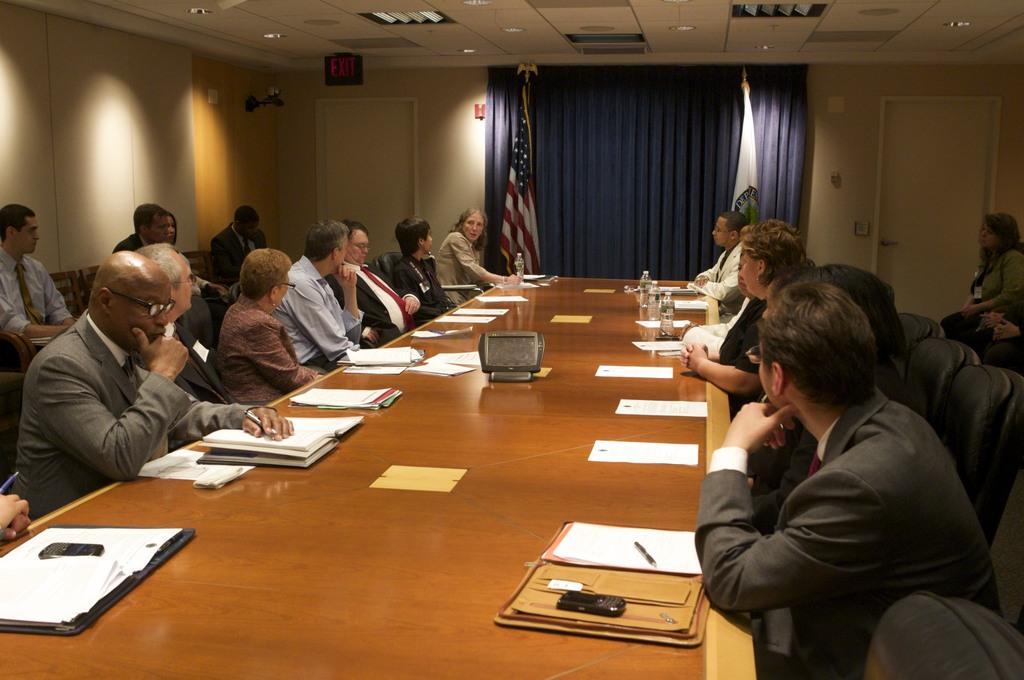How would you summarize this image in a sentence or two? This picture shows a meeting room were all the people seated on the chairs and we see e some papers ,water bottles on the table and we see to flags and a curtain on the wall 